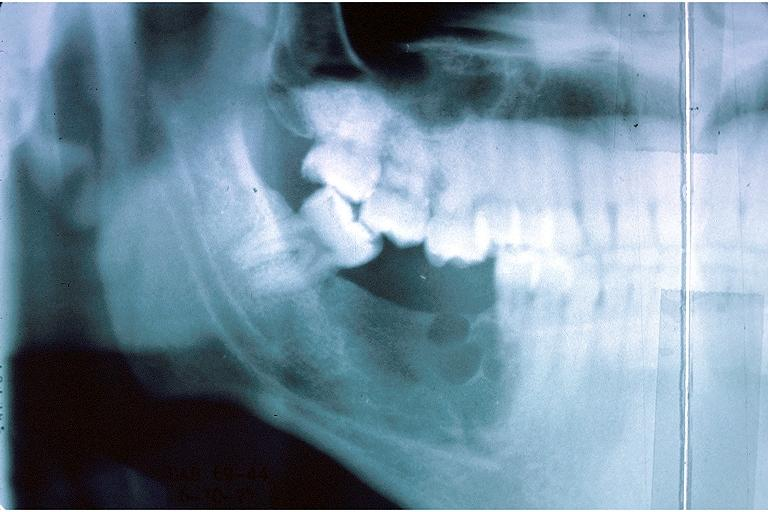does polysplenia show ameloblastic fibroma?
Answer the question using a single word or phrase. No 